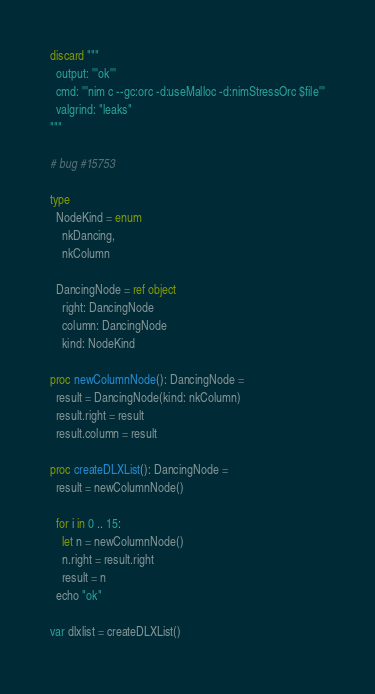<code> <loc_0><loc_0><loc_500><loc_500><_Nim_>discard """
  output: '''ok'''
  cmd: '''nim c --gc:orc -d:useMalloc -d:nimStressOrc $file'''
  valgrind: "leaks"
"""

# bug #15753

type
  NodeKind = enum
    nkDancing,
    nkColumn

  DancingNode = ref object
    right: DancingNode
    column: DancingNode
    kind: NodeKind

proc newColumnNode(): DancingNode =
  result = DancingNode(kind: nkColumn)
  result.right = result
  result.column = result

proc createDLXList(): DancingNode =
  result = newColumnNode()

  for i in 0 .. 15:
    let n = newColumnNode()
    n.right = result.right
    result = n
  echo "ok"

var dlxlist = createDLXList()
</code> 